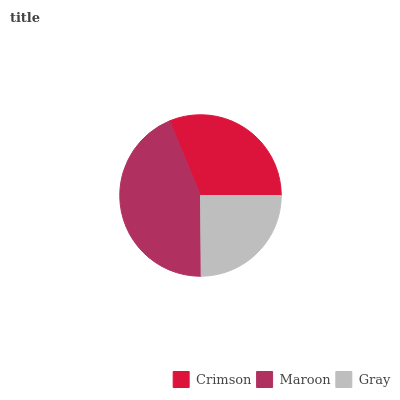Is Gray the minimum?
Answer yes or no. Yes. Is Maroon the maximum?
Answer yes or no. Yes. Is Maroon the minimum?
Answer yes or no. No. Is Gray the maximum?
Answer yes or no. No. Is Maroon greater than Gray?
Answer yes or no. Yes. Is Gray less than Maroon?
Answer yes or no. Yes. Is Gray greater than Maroon?
Answer yes or no. No. Is Maroon less than Gray?
Answer yes or no. No. Is Crimson the high median?
Answer yes or no. Yes. Is Crimson the low median?
Answer yes or no. Yes. Is Maroon the high median?
Answer yes or no. No. Is Maroon the low median?
Answer yes or no. No. 